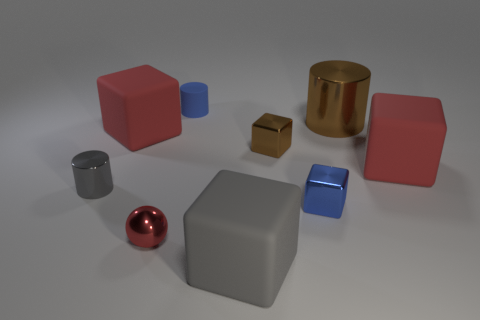Subtract all tiny brown blocks. How many blocks are left? 4 Subtract all purple blocks. Subtract all purple cylinders. How many blocks are left? 5 Add 1 tiny matte cubes. How many objects exist? 10 Subtract all spheres. How many objects are left? 8 Add 6 large blue matte cylinders. How many large blue matte cylinders exist? 6 Subtract 0 purple spheres. How many objects are left? 9 Subtract all big gray things. Subtract all small red shiny balls. How many objects are left? 7 Add 6 red matte objects. How many red matte objects are left? 8 